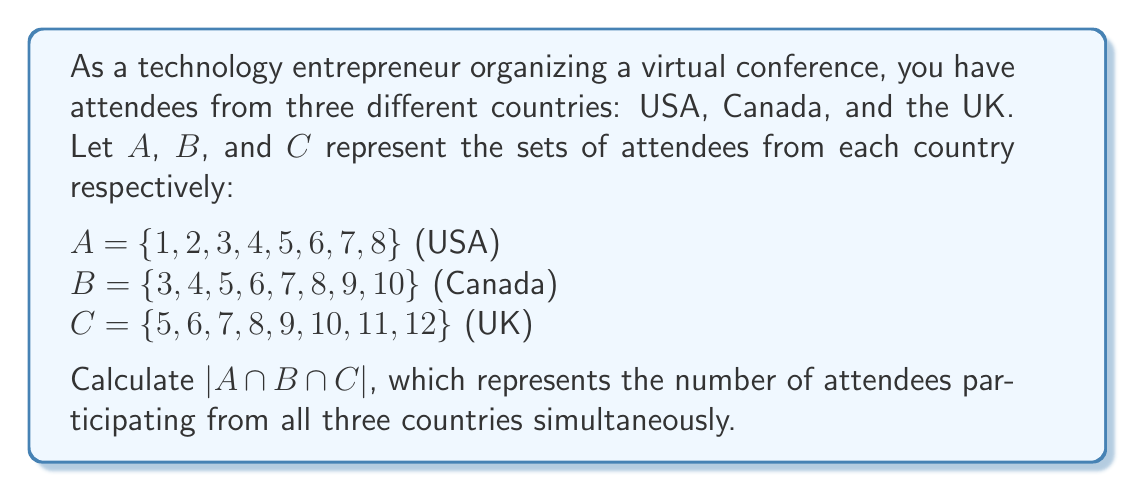Provide a solution to this math problem. To solve this problem, we need to find the intersection of all three sets and then determine its cardinality. Let's approach this step-by-step:

1) First, let's identify the elements that are common to all three sets:
   $A \cap B \cap C = \{5, 6, 7, 8\}$

   We can see that these four elements appear in all three sets.

2) The cardinality of a set is denoted by vertical bars around the set. In this case:
   $|A \cap B \cap C| = |\{5, 6, 7, 8\}|$

3) To find the cardinality, we simply count the number of elements in the set:
   $|A \cap B \cap C| = 4$

This result indicates that there are 4 attendees who are participating from all three countries simultaneously. As a technology entrepreneur, this information could be valuable for understanding the global reach of your virtual conference and potentially for planning breakout sessions or networking opportunities that bring together participants from diverse geographical backgrounds.
Answer: $|A \cap B \cap C| = 4$ 